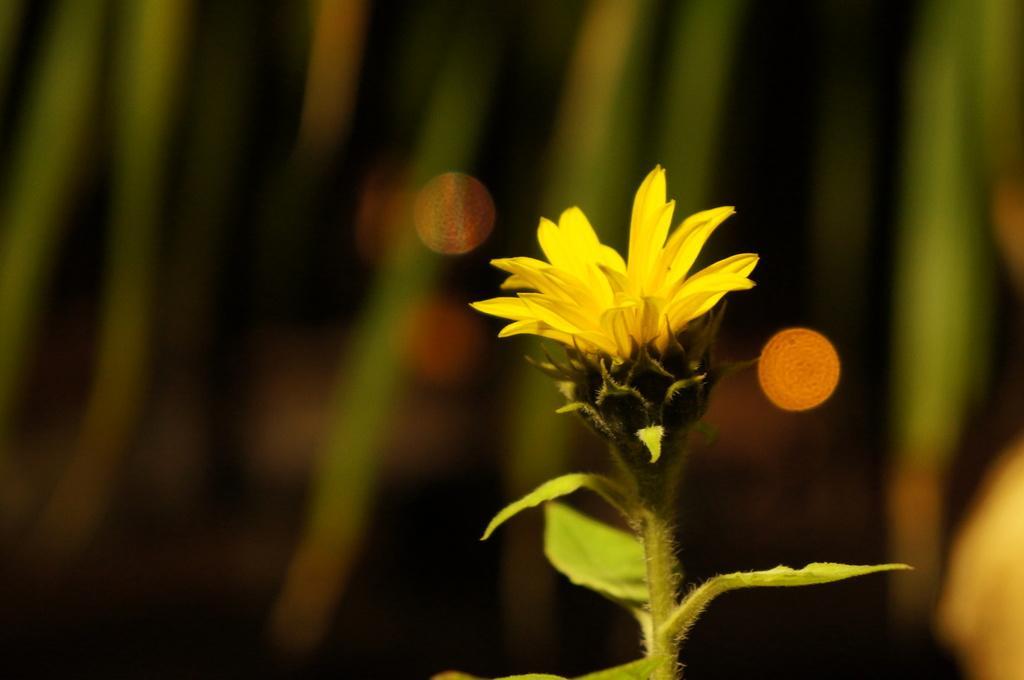Can you describe this image briefly? In this image we can see one yellow color flower with stem and leaves. There is green color background with golden reddish dots. 